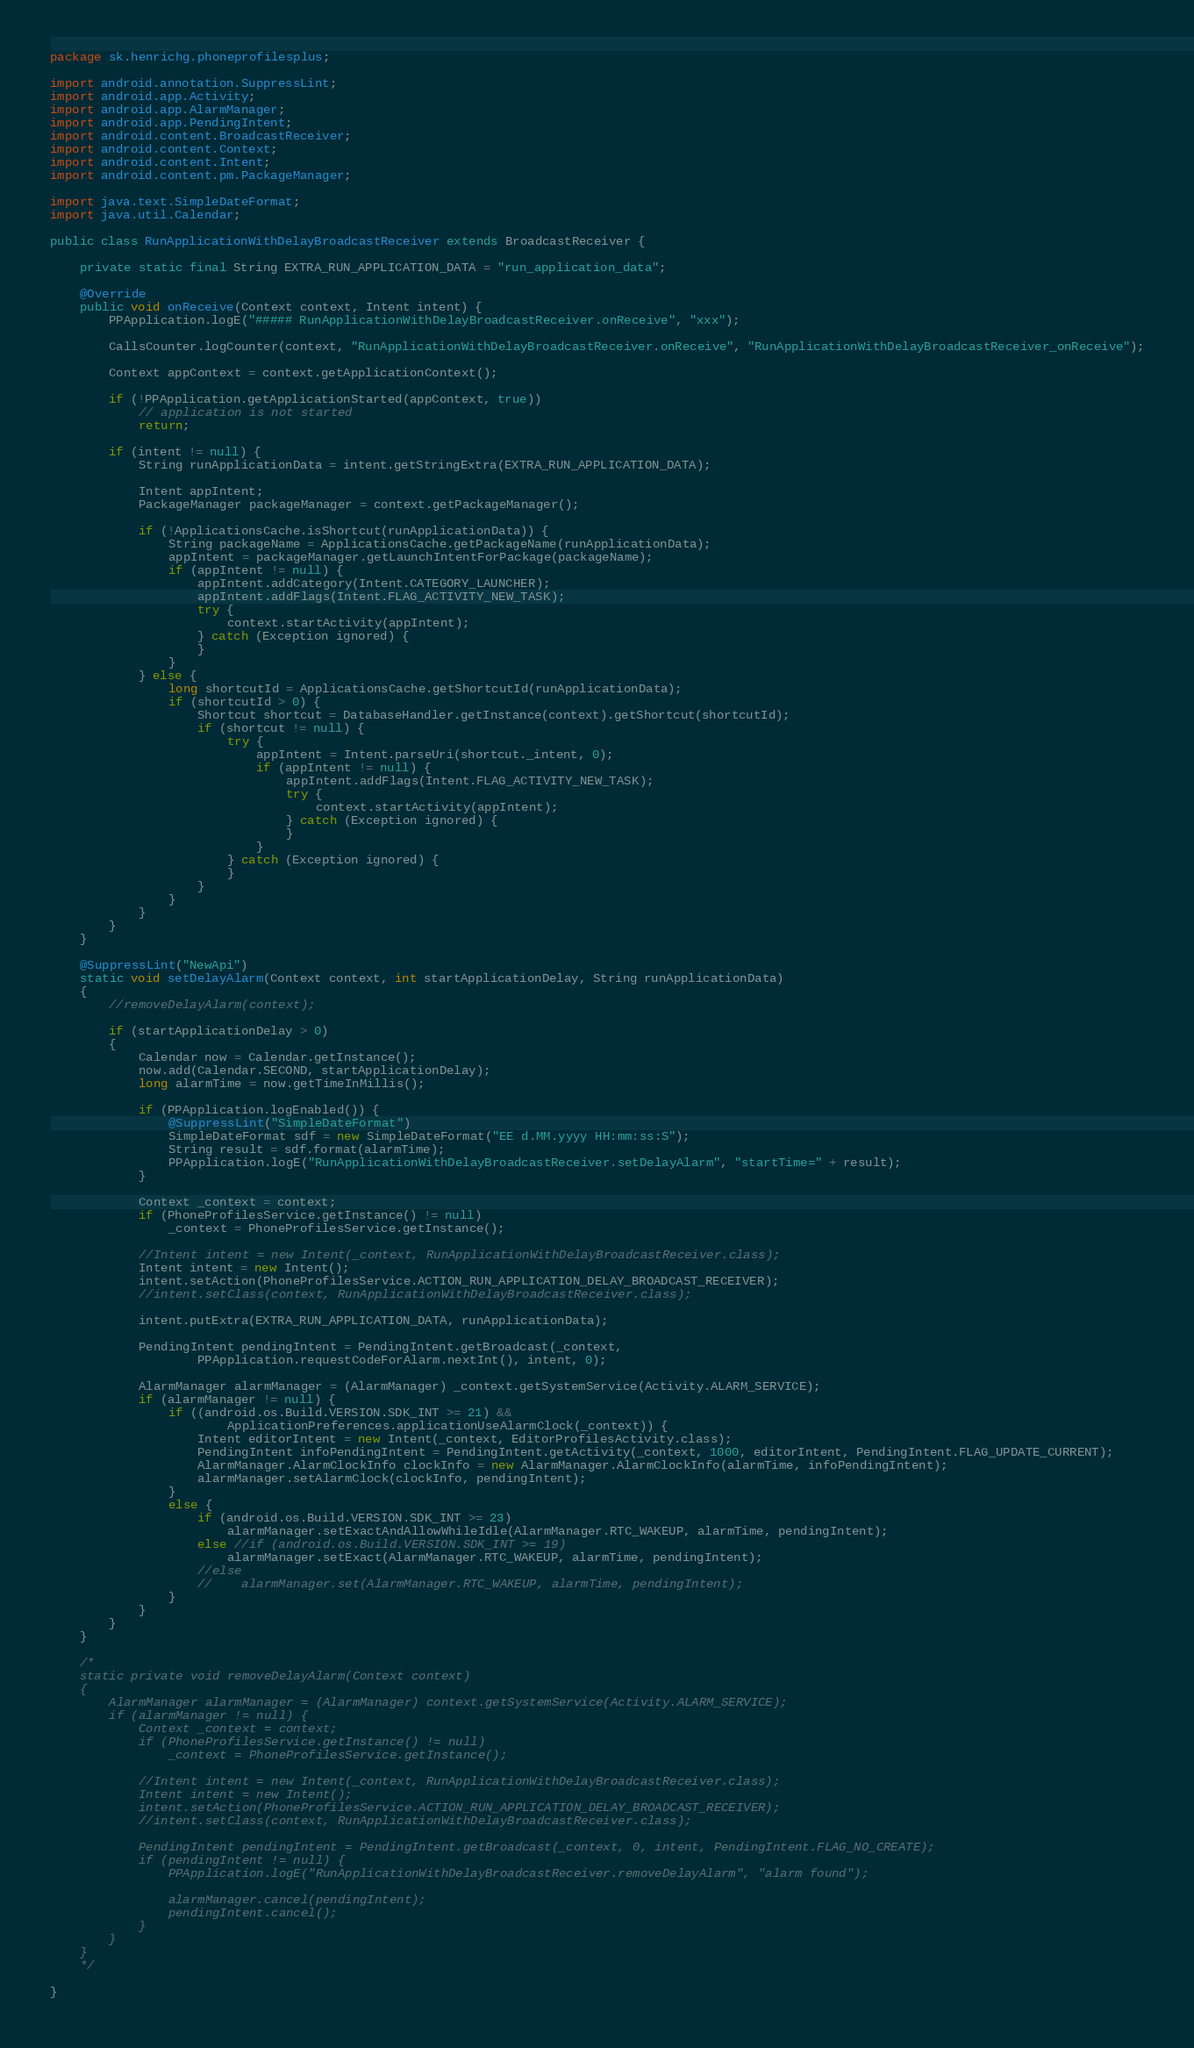Convert code to text. <code><loc_0><loc_0><loc_500><loc_500><_Java_>package sk.henrichg.phoneprofilesplus;

import android.annotation.SuppressLint;
import android.app.Activity;
import android.app.AlarmManager;
import android.app.PendingIntent;
import android.content.BroadcastReceiver;
import android.content.Context;
import android.content.Intent;
import android.content.pm.PackageManager;

import java.text.SimpleDateFormat;
import java.util.Calendar;

public class RunApplicationWithDelayBroadcastReceiver extends BroadcastReceiver {

    private static final String EXTRA_RUN_APPLICATION_DATA = "run_application_data";

    @Override
    public void onReceive(Context context, Intent intent) {
        PPApplication.logE("##### RunApplicationWithDelayBroadcastReceiver.onReceive", "xxx");

        CallsCounter.logCounter(context, "RunApplicationWithDelayBroadcastReceiver.onReceive", "RunApplicationWithDelayBroadcastReceiver_onReceive");

        Context appContext = context.getApplicationContext();

        if (!PPApplication.getApplicationStarted(appContext, true))
            // application is not started
            return;

        if (intent != null) {
            String runApplicationData = intent.getStringExtra(EXTRA_RUN_APPLICATION_DATA);

            Intent appIntent;
            PackageManager packageManager = context.getPackageManager();

            if (!ApplicationsCache.isShortcut(runApplicationData)) {
                String packageName = ApplicationsCache.getPackageName(runApplicationData);
                appIntent = packageManager.getLaunchIntentForPackage(packageName);
                if (appIntent != null) {
                    appIntent.addCategory(Intent.CATEGORY_LAUNCHER);
                    appIntent.addFlags(Intent.FLAG_ACTIVITY_NEW_TASK);
                    try {
                        context.startActivity(appIntent);
                    } catch (Exception ignored) {
                    }
                }
            } else {
                long shortcutId = ApplicationsCache.getShortcutId(runApplicationData);
                if (shortcutId > 0) {
                    Shortcut shortcut = DatabaseHandler.getInstance(context).getShortcut(shortcutId);
                    if (shortcut != null) {
                        try {
                            appIntent = Intent.parseUri(shortcut._intent, 0);
                            if (appIntent != null) {
                                appIntent.addFlags(Intent.FLAG_ACTIVITY_NEW_TASK);
                                try {
                                    context.startActivity(appIntent);
                                } catch (Exception ignored) {
                                }
                            }
                        } catch (Exception ignored) {
                        }
                    }
                }
            }
        }
    }

    @SuppressLint("NewApi")
    static void setDelayAlarm(Context context, int startApplicationDelay, String runApplicationData)
    {
        //removeDelayAlarm(context);

        if (startApplicationDelay > 0)
        {
            Calendar now = Calendar.getInstance();
            now.add(Calendar.SECOND, startApplicationDelay);
            long alarmTime = now.getTimeInMillis();

            if (PPApplication.logEnabled()) {
                @SuppressLint("SimpleDateFormat")
                SimpleDateFormat sdf = new SimpleDateFormat("EE d.MM.yyyy HH:mm:ss:S");
                String result = sdf.format(alarmTime);
                PPApplication.logE("RunApplicationWithDelayBroadcastReceiver.setDelayAlarm", "startTime=" + result);
            }

            Context _context = context;
            if (PhoneProfilesService.getInstance() != null)
                _context = PhoneProfilesService.getInstance();

            //Intent intent = new Intent(_context, RunApplicationWithDelayBroadcastReceiver.class);
            Intent intent = new Intent();
            intent.setAction(PhoneProfilesService.ACTION_RUN_APPLICATION_DELAY_BROADCAST_RECEIVER);
            //intent.setClass(context, RunApplicationWithDelayBroadcastReceiver.class);

            intent.putExtra(EXTRA_RUN_APPLICATION_DATA, runApplicationData);

            PendingIntent pendingIntent = PendingIntent.getBroadcast(_context,
                    PPApplication.requestCodeForAlarm.nextInt(), intent, 0);

            AlarmManager alarmManager = (AlarmManager) _context.getSystemService(Activity.ALARM_SERVICE);
            if (alarmManager != null) {
                if ((android.os.Build.VERSION.SDK_INT >= 21) &&
                        ApplicationPreferences.applicationUseAlarmClock(_context)) {
                    Intent editorIntent = new Intent(_context, EditorProfilesActivity.class);
                    PendingIntent infoPendingIntent = PendingIntent.getActivity(_context, 1000, editorIntent, PendingIntent.FLAG_UPDATE_CURRENT);
                    AlarmManager.AlarmClockInfo clockInfo = new AlarmManager.AlarmClockInfo(alarmTime, infoPendingIntent);
                    alarmManager.setAlarmClock(clockInfo, pendingIntent);
                }
                else {
                    if (android.os.Build.VERSION.SDK_INT >= 23)
                        alarmManager.setExactAndAllowWhileIdle(AlarmManager.RTC_WAKEUP, alarmTime, pendingIntent);
                    else //if (android.os.Build.VERSION.SDK_INT >= 19)
                        alarmManager.setExact(AlarmManager.RTC_WAKEUP, alarmTime, pendingIntent);
                    //else
                    //    alarmManager.set(AlarmManager.RTC_WAKEUP, alarmTime, pendingIntent);
                }
            }
        }
    }

    /*
    static private void removeDelayAlarm(Context context)
    {
        AlarmManager alarmManager = (AlarmManager) context.getSystemService(Activity.ALARM_SERVICE);
        if (alarmManager != null) {
            Context _context = context;
            if (PhoneProfilesService.getInstance() != null)
                _context = PhoneProfilesService.getInstance();

            //Intent intent = new Intent(_context, RunApplicationWithDelayBroadcastReceiver.class);
            Intent intent = new Intent();
            intent.setAction(PhoneProfilesService.ACTION_RUN_APPLICATION_DELAY_BROADCAST_RECEIVER);
            //intent.setClass(context, RunApplicationWithDelayBroadcastReceiver.class);

            PendingIntent pendingIntent = PendingIntent.getBroadcast(_context, 0, intent, PendingIntent.FLAG_NO_CREATE);
            if (pendingIntent != null) {
                PPApplication.logE("RunApplicationWithDelayBroadcastReceiver.removeDelayAlarm", "alarm found");

                alarmManager.cancel(pendingIntent);
                pendingIntent.cancel();
            }
        }
    }
    */

}
</code> 